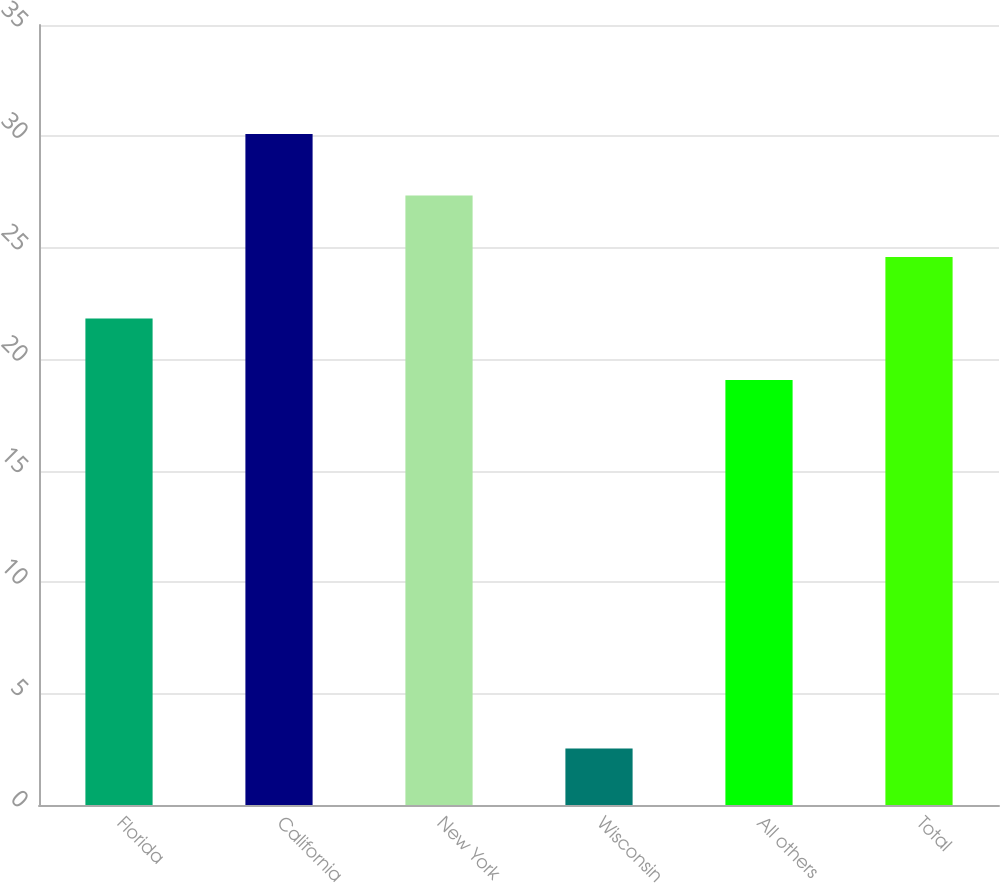<chart> <loc_0><loc_0><loc_500><loc_500><bar_chart><fcel>Florida<fcel>California<fcel>New York<fcel>Wisconsin<fcel>All others<fcel>Total<nl><fcel>21.83<fcel>30.11<fcel>27.35<fcel>2.54<fcel>19.07<fcel>24.59<nl></chart> 